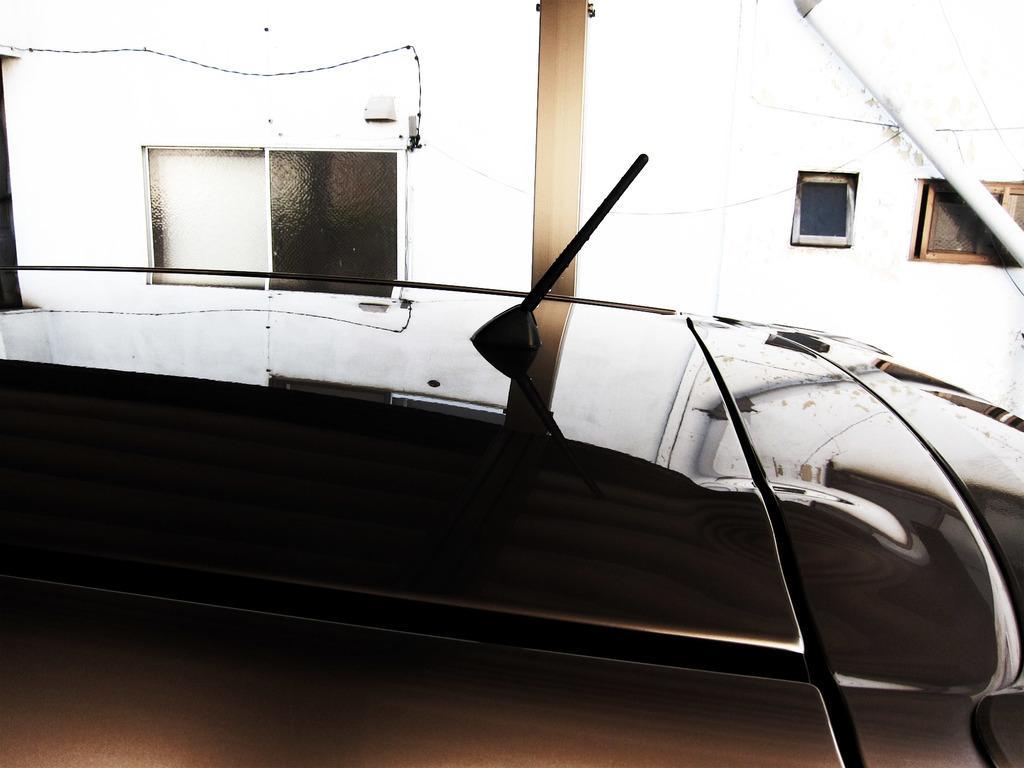Please provide a concise description of this image. In this image, we can see a vehicle with antenna and reflections. In the background, there are glass windows, wall, pillar and pole. 